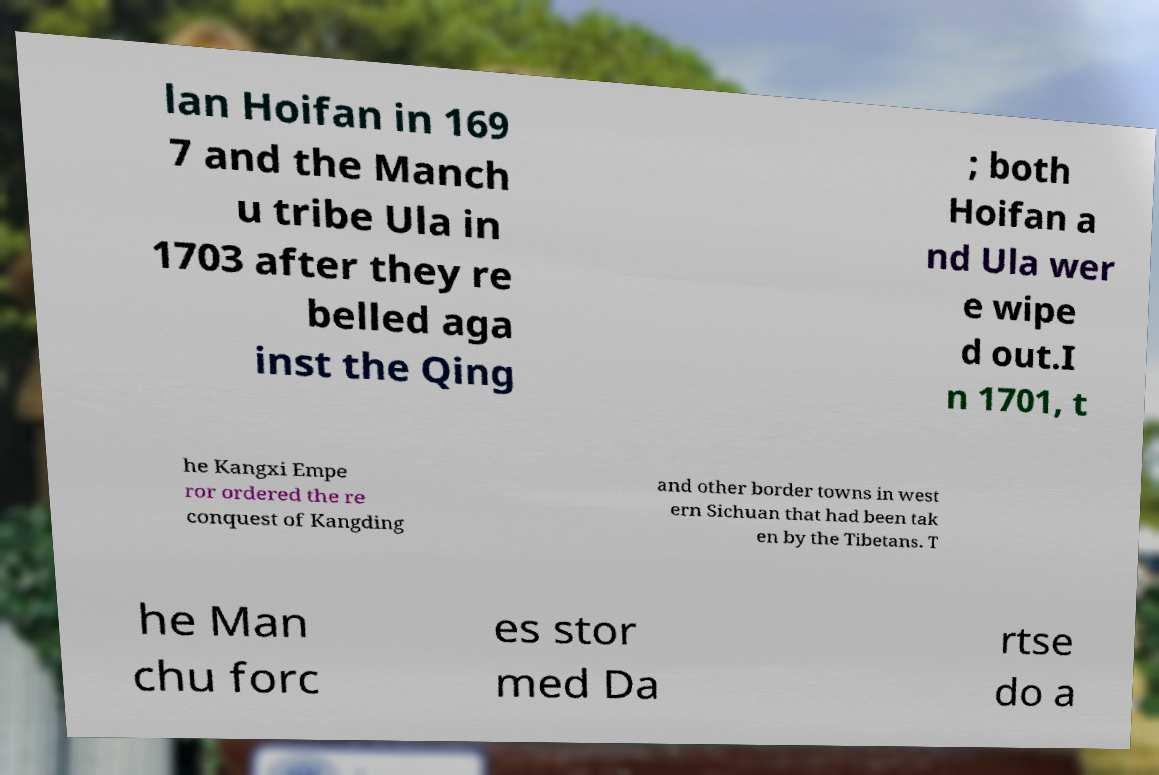Could you assist in decoding the text presented in this image and type it out clearly? lan Hoifan in 169 7 and the Manch u tribe Ula in 1703 after they re belled aga inst the Qing ; both Hoifan a nd Ula wer e wipe d out.I n 1701, t he Kangxi Empe ror ordered the re conquest of Kangding and other border towns in west ern Sichuan that had been tak en by the Tibetans. T he Man chu forc es stor med Da rtse do a 